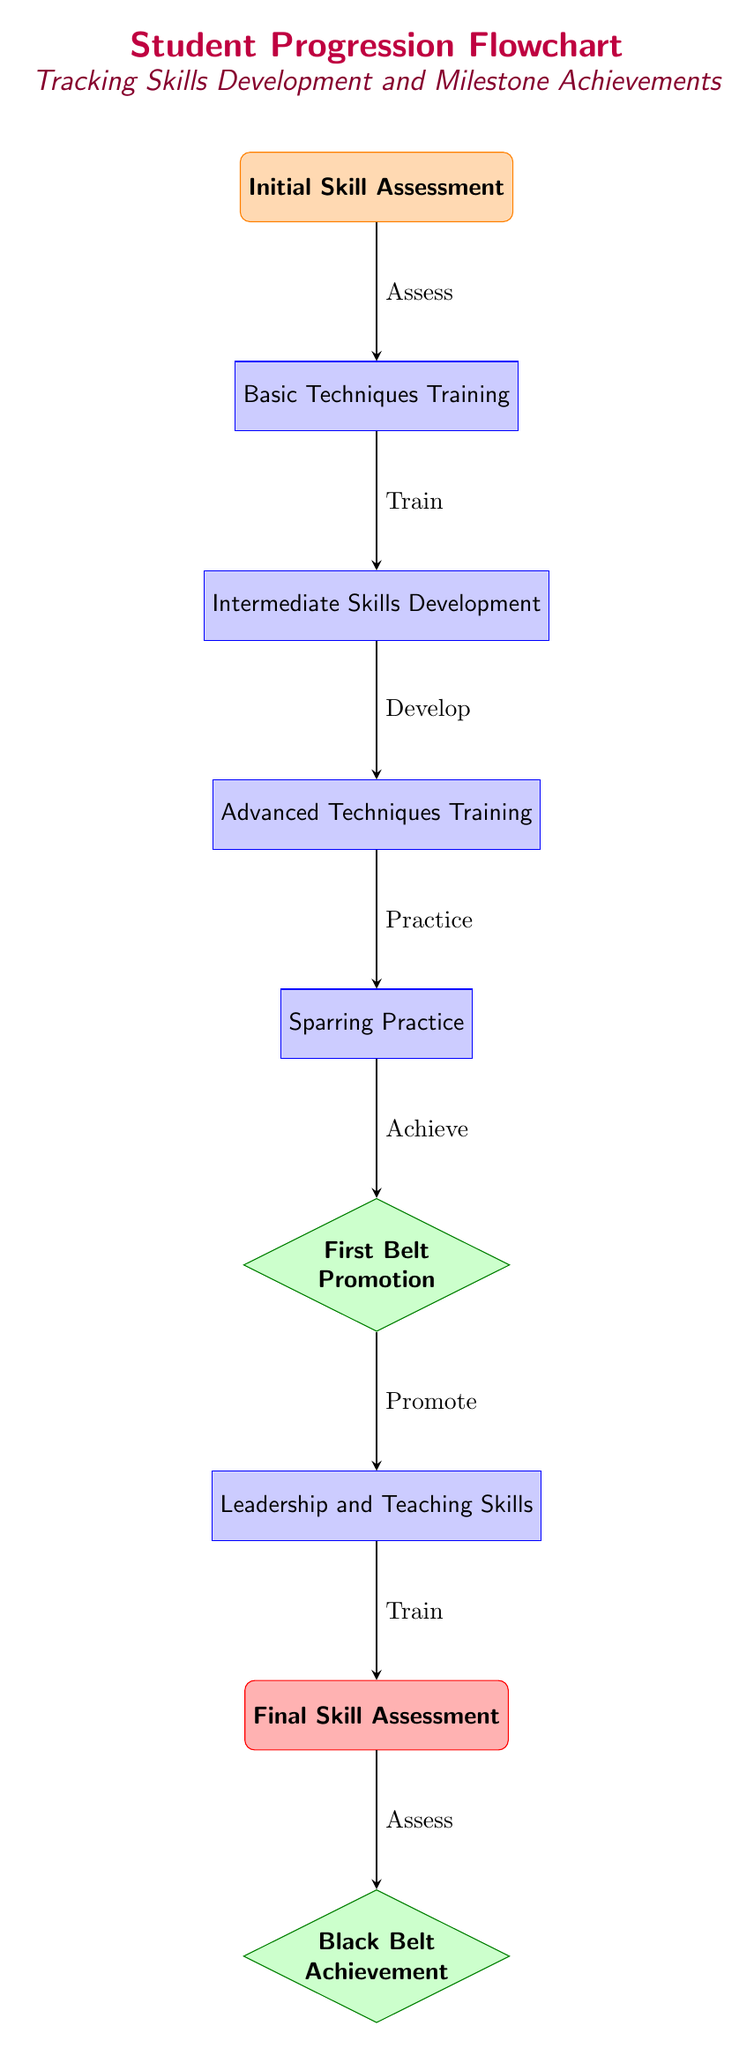What is the first step in the flowchart? The diagram begins with the "Initial Skill Assessment" node, indicating it is the first step.
Answer: Initial Skill Assessment How many process nodes are in the flowchart? The process nodes include: Basic Techniques Training, Intermediate Skills Development, Advanced Techniques Training, Sparring Practice, Leadership and Teaching Skills, and Final Skill Assessment, totaling six process nodes.
Answer: 6 What milestone comes after Sparring Practice? The diagram shows that the milestone following Sparring Practice is "First Belt Promotion."
Answer: First Belt Promotion What action follows after the "Final Skill Assessment"? According to the flowchart, the action that follows is the assessment for "Black Belt Achievement."
Answer: Assess What is the relationship between "Basic Techniques Training" and "Intermediate Skills Development"? The flowchart displays an arrow from "Basic Techniques Training" to "Intermediate Skills Development," indicating that the former leads to the latter.
Answer: Train Which milestone indicates a student's first significant achievement? The flowchart presents "First Belt Promotion" as the first major milestone a student achieves.
Answer: First Belt Promotion How many arrows connect the nodes in the diagram? By examining the diagram, there are a total of seven arrows connecting the nodes, indicating the flow of progression.
Answer: 7 What indicates the completion of the student progression flow? The final node labeled "Black Belt Achievement" is the indication of the completion of the student's progression through the flowchart.
Answer: Black Belt Achievement What is the last process node before the final assessment? The last process node prior to the final assessment is "Leadership and Teaching Skills."
Answer: Leadership and Teaching Skills 